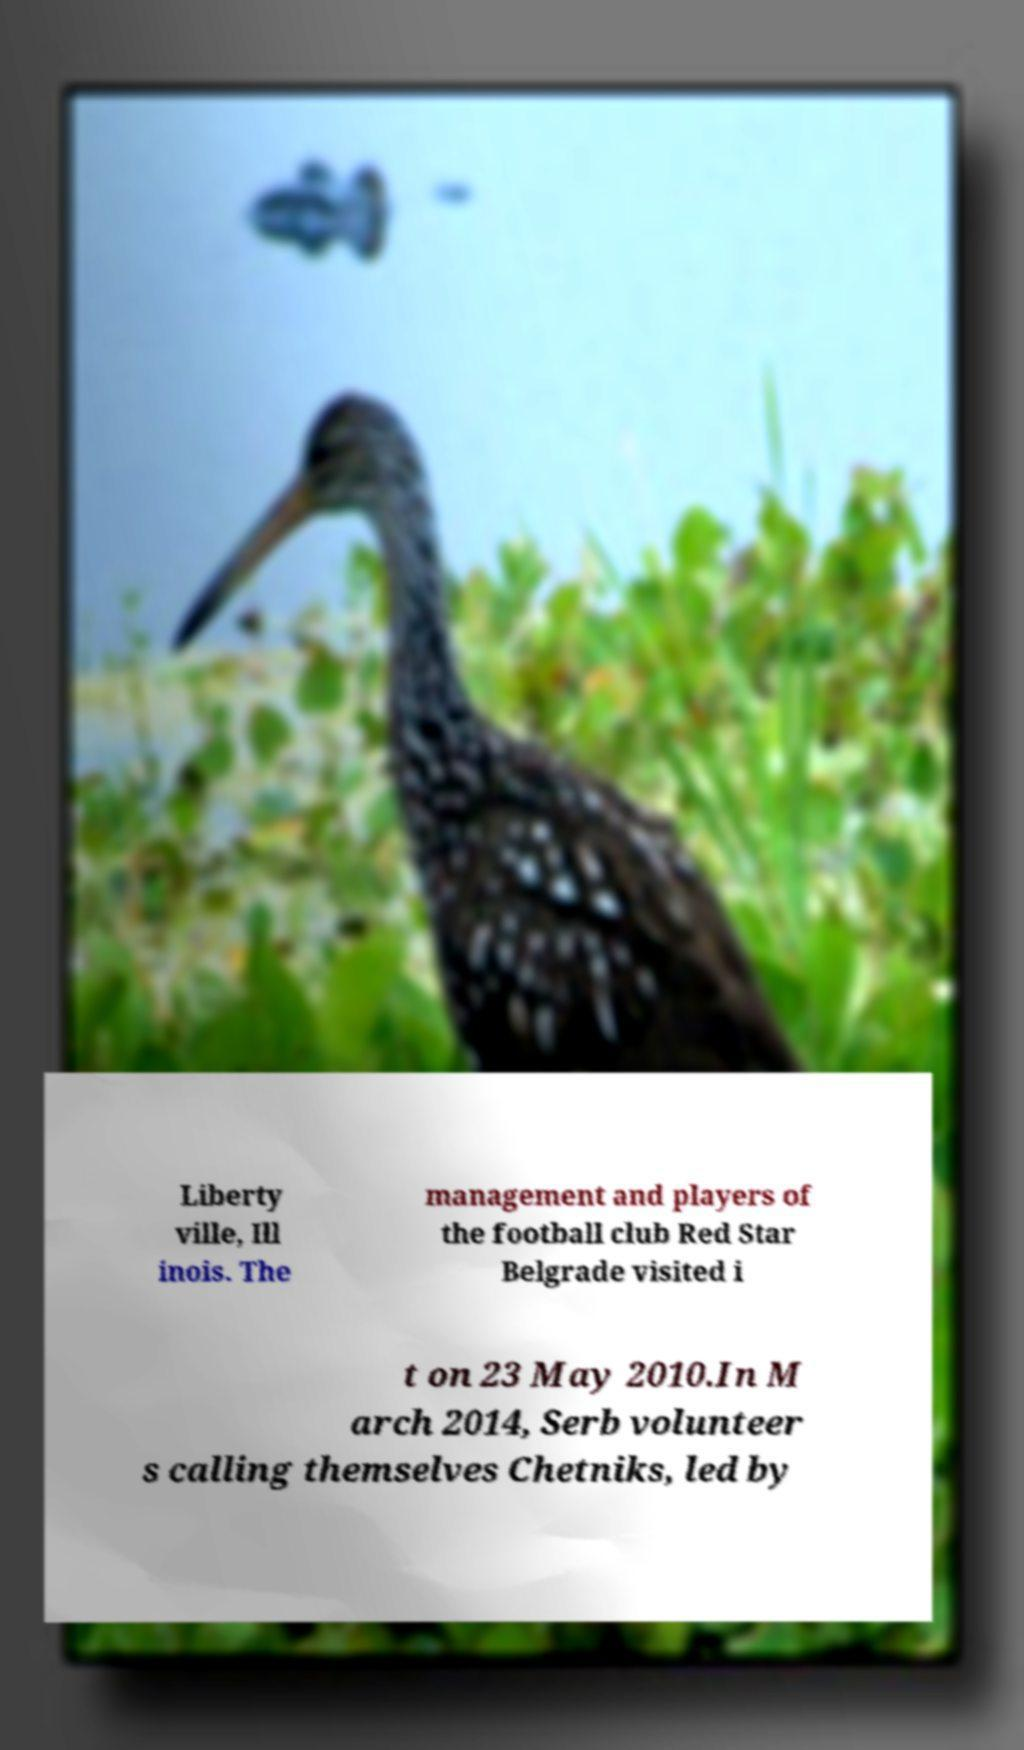Can you read and provide the text displayed in the image?This photo seems to have some interesting text. Can you extract and type it out for me? Liberty ville, Ill inois. The management and players of the football club Red Star Belgrade visited i t on 23 May 2010.In M arch 2014, Serb volunteer s calling themselves Chetniks, led by 